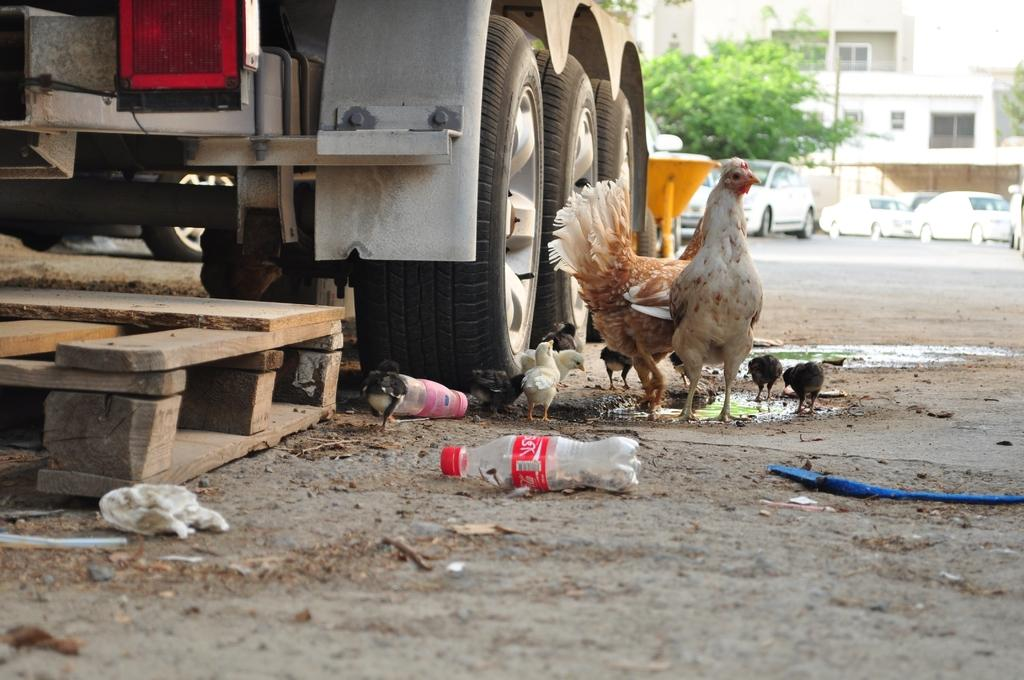What type of animal can be seen in the image? There is a hen in the image. Are there any baby animals present? Yes, there are chicks in the image. What object is used for drinking in the image? There is a water bottle in the image. Can you describe the setting of the image? The image contains a road, a tree, a pole, a building, and the sky is visible. What type of vehicles are in the image? There is a truck and a car in the image. Are there any structures for people to walk on? Yes, there are wooden steps in the image. How much money is being exchanged between the hen and the chicks in the image? There is no money being exchanged in the image; it features a hen and chicks in a setting with various objects and structures. What type of nerve is being stimulated by the boat in the image? There is no boat present in the image, so it is not possible to determine which nerve might be stimulated. 